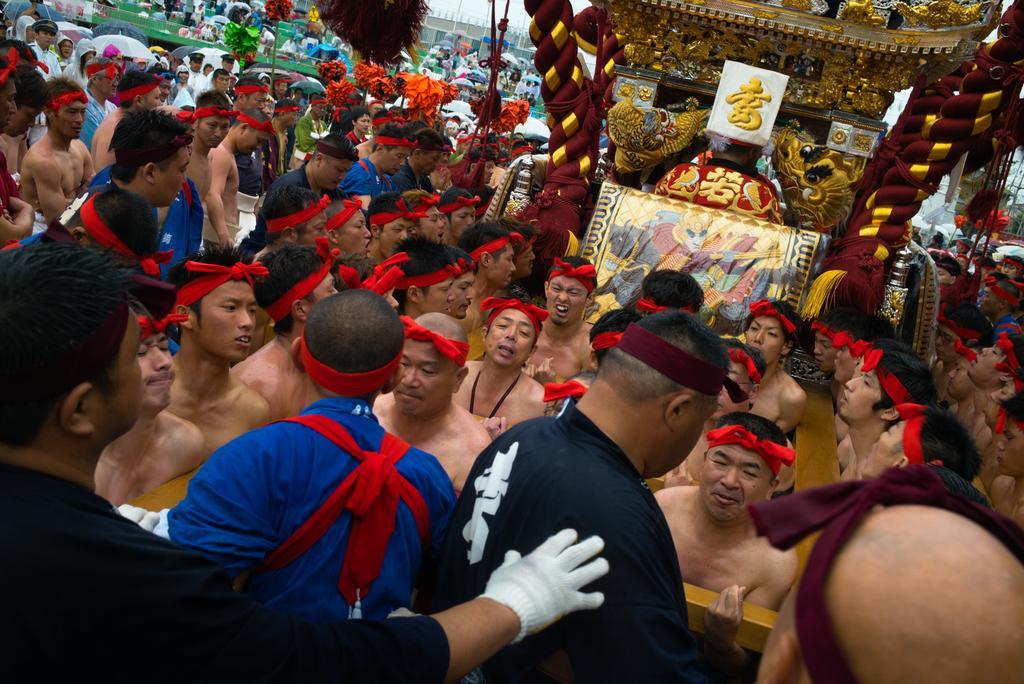Can you describe this image briefly? In this image I see number of people and I see a red board and silver color thing over here and I see something is written over here. 